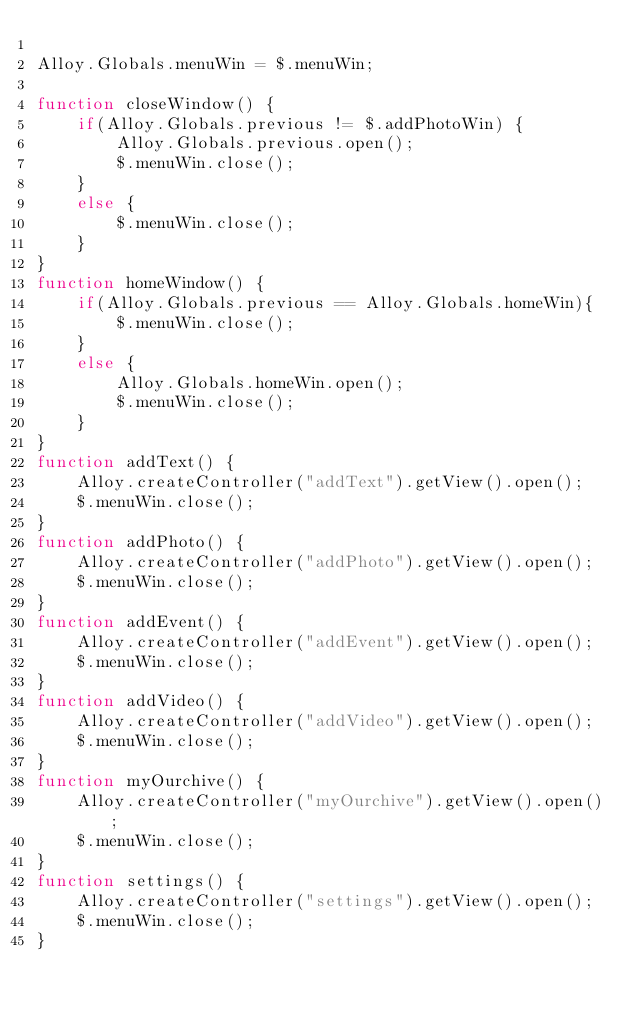Convert code to text. <code><loc_0><loc_0><loc_500><loc_500><_JavaScript_>
Alloy.Globals.menuWin = $.menuWin;

function closeWindow() {
	if(Alloy.Globals.previous != $.addPhotoWin) {
		Alloy.Globals.previous.open();
		$.menuWin.close();
	}
	else {
		$.menuWin.close();
	}
}
function homeWindow() {
	if(Alloy.Globals.previous == Alloy.Globals.homeWin){
		$.menuWin.close();
	}
	else {
		Alloy.Globals.homeWin.open();
		$.menuWin.close();
	}
}
function addText() {
	Alloy.createController("addText").getView().open();
	$.menuWin.close();
}
function addPhoto() {
	Alloy.createController("addPhoto").getView().open();
	$.menuWin.close();
}
function addEvent() {
	Alloy.createController("addEvent").getView().open();
	$.menuWin.close();
}
function addVideo() {
	Alloy.createController("addVideo").getView().open();
	$.menuWin.close();
}
function myOurchive() {
	Alloy.createController("myOurchive").getView().open();
	$.menuWin.close();
}
function settings() {
	Alloy.createController("settings").getView().open();
	$.menuWin.close();
}</code> 